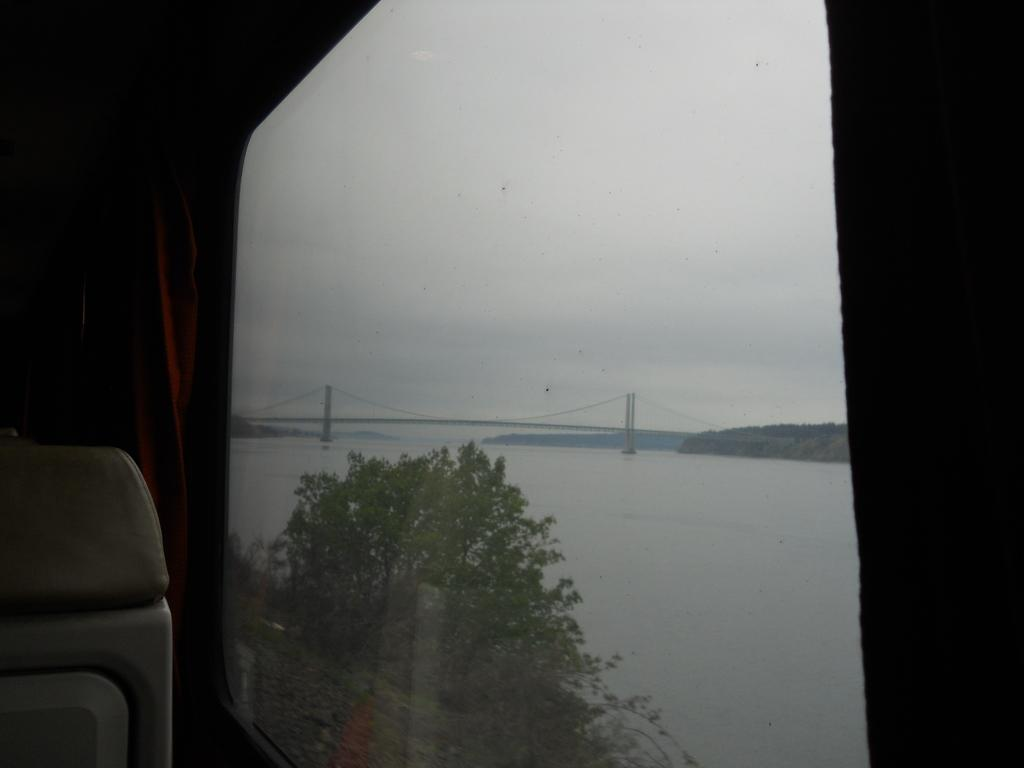What type of vehicle is in the image? The type of vehicle is not specified in the facts. What is the setting of the image? The image features water, trees, a bridge, and a cloudy sky. Can you describe the water in the image? The water is visible in the image, but its characteristics are not specified. What is the purpose of the bridge in the image? The purpose of the bridge is not specified in the facts. What is the value of the winter season in the image? There is no mention of a winter season in the image, so it is not possible to determine its value. 